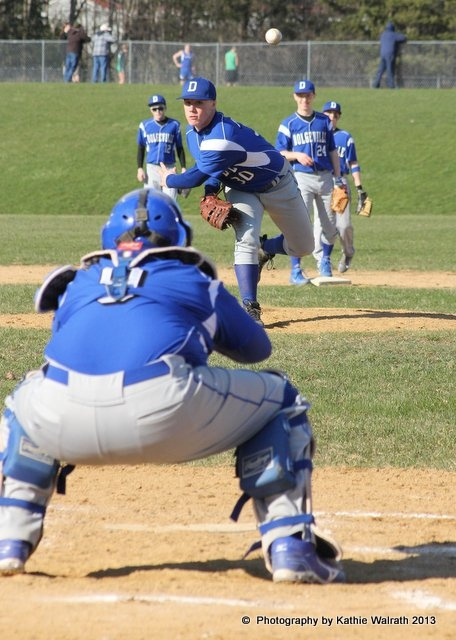Describe the objects in this image and their specific colors. I can see people in gray, lightgray, lightblue, and navy tones, people in gray, navy, and black tones, people in gray, lightgray, and navy tones, people in gray, lightgray, navy, and black tones, and people in gray, darkgray, and lightgray tones in this image. 